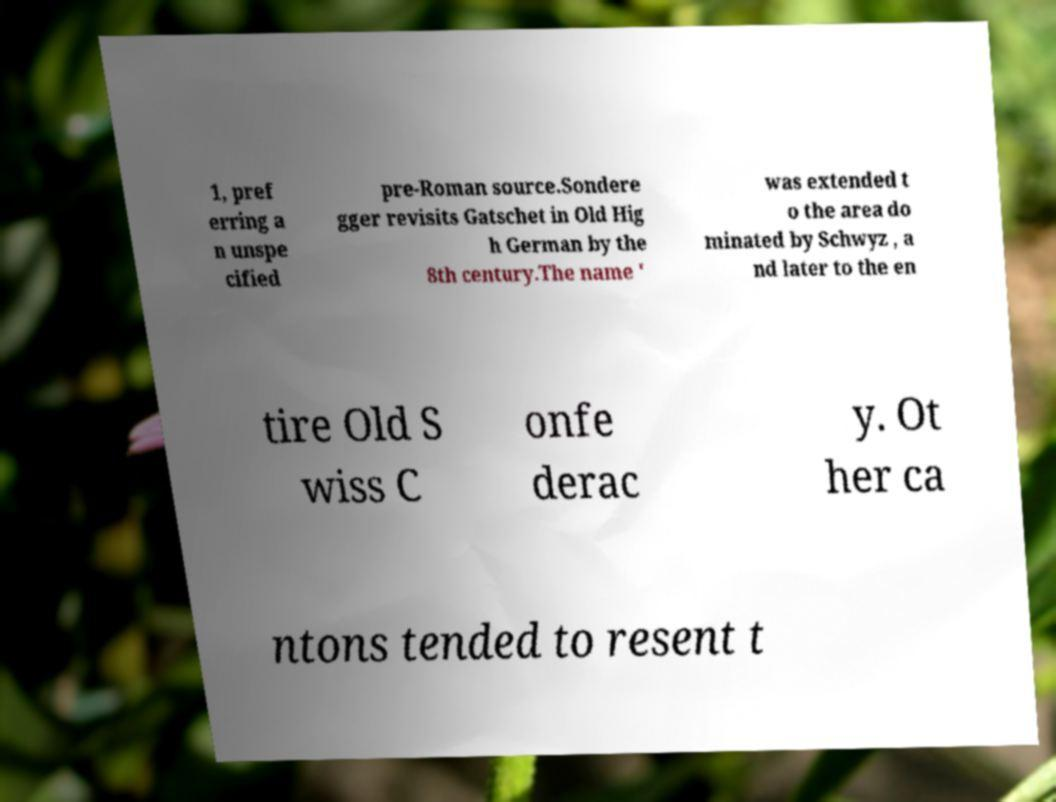For documentation purposes, I need the text within this image transcribed. Could you provide that? 1, pref erring a n unspe cified pre-Roman source.Sondere gger revisits Gatschet in Old Hig h German by the 8th century.The name ' was extended t o the area do minated by Schwyz , a nd later to the en tire Old S wiss C onfe derac y. Ot her ca ntons tended to resent t 